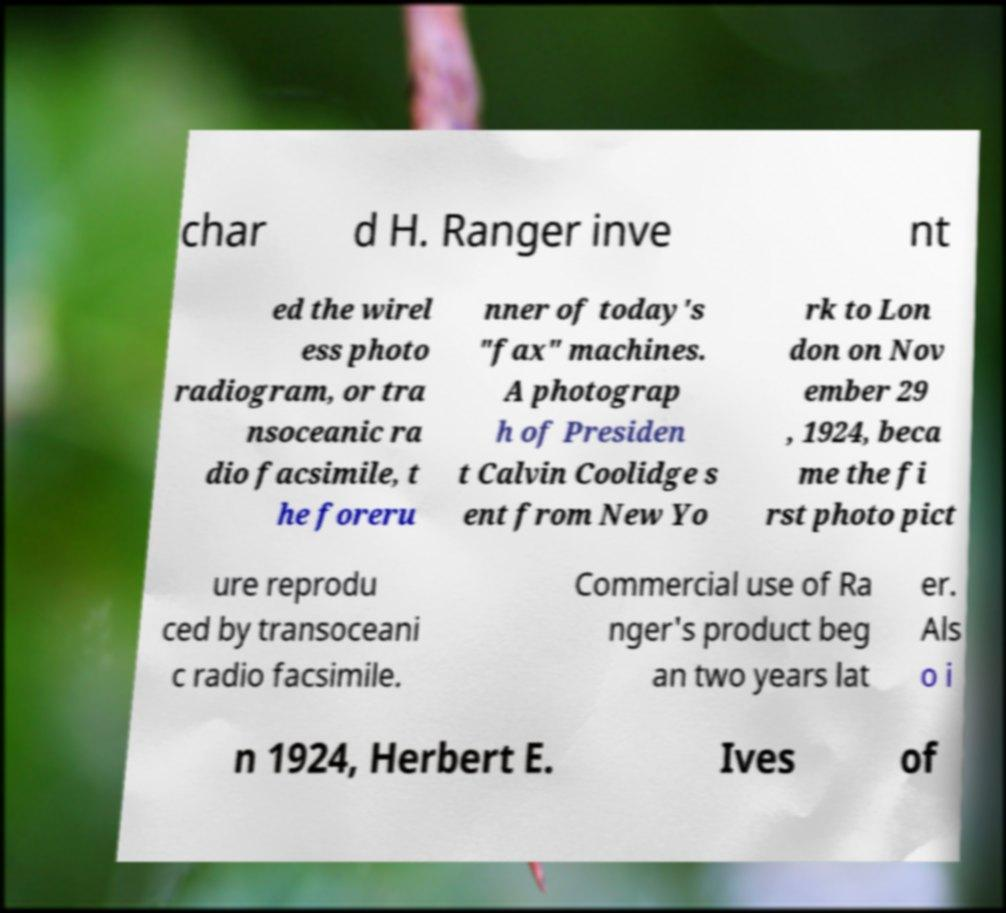For documentation purposes, I need the text within this image transcribed. Could you provide that? char d H. Ranger inve nt ed the wirel ess photo radiogram, or tra nsoceanic ra dio facsimile, t he foreru nner of today's "fax" machines. A photograp h of Presiden t Calvin Coolidge s ent from New Yo rk to Lon don on Nov ember 29 , 1924, beca me the fi rst photo pict ure reprodu ced by transoceani c radio facsimile. Commercial use of Ra nger's product beg an two years lat er. Als o i n 1924, Herbert E. Ives of 